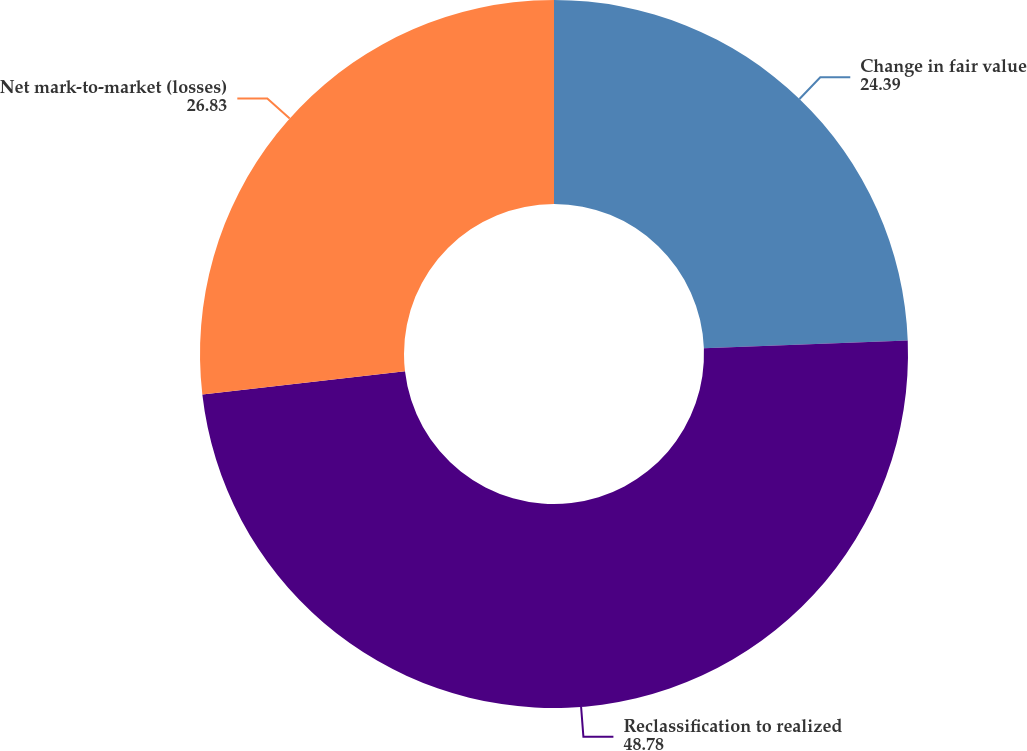Convert chart to OTSL. <chart><loc_0><loc_0><loc_500><loc_500><pie_chart><fcel>Change in fair value<fcel>Reclassification to realized<fcel>Net mark-to-market (losses)<nl><fcel>24.39%<fcel>48.78%<fcel>26.83%<nl></chart> 